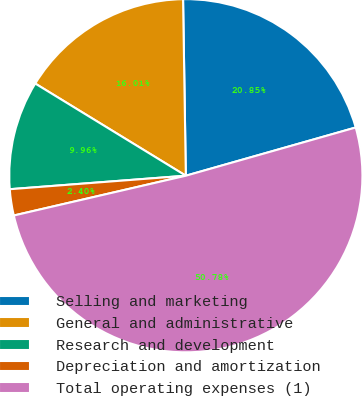Convert chart to OTSL. <chart><loc_0><loc_0><loc_500><loc_500><pie_chart><fcel>Selling and marketing<fcel>General and administrative<fcel>Research and development<fcel>Depreciation and amortization<fcel>Total operating expenses (1)<nl><fcel>20.85%<fcel>16.01%<fcel>9.96%<fcel>2.4%<fcel>50.79%<nl></chart> 